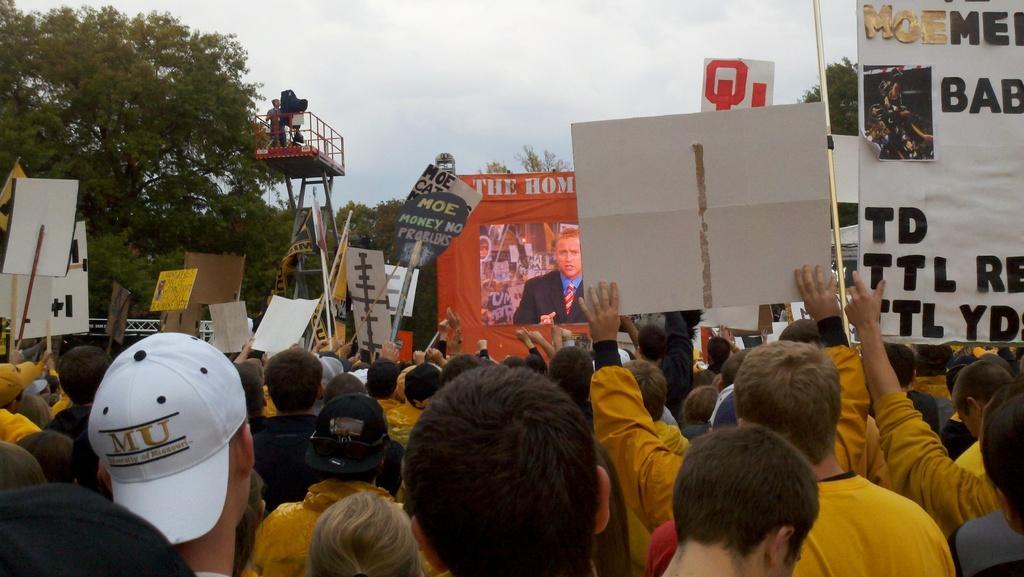How would you summarize this image in a sentence or two? In the foreground, I can see boards, posters and a crowd on the road. In the background, I can see trees, vehicles, metal rods, fence and the sky. This image is taken, maybe during a day. 